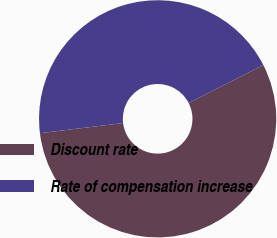Convert chart. <chart><loc_0><loc_0><loc_500><loc_500><pie_chart><fcel>Discount rate<fcel>Rate of compensation increase<nl><fcel>55.56%<fcel>44.44%<nl></chart> 